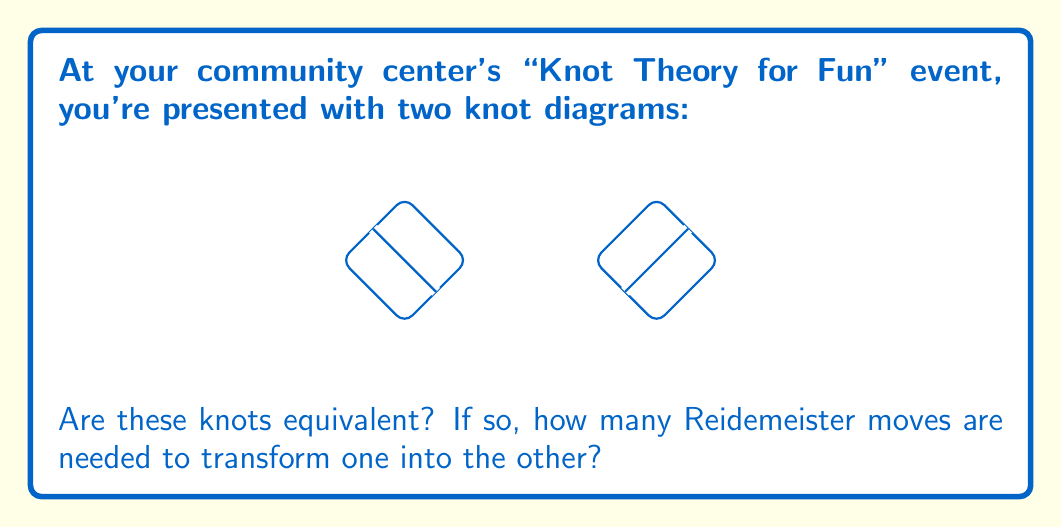Show me your answer to this math problem. To determine if two knots are equivalent using Reidemeister moves, we need to analyze the given diagrams and apply the appropriate moves. Let's approach this step-by-step:

1. Observe the knots:
   - Knot 1 is a right-handed trefoil knot
   - Knot 2 is a left-handed trefoil knot

2. Recall the three types of Reidemeister moves:
   - Type I: Twisting or untwisting a strand
   - Type II: Moving one strand completely over or under another
   - Type III: Moving a strand over or under a crossing

3. To transform the right-handed trefoil to a left-handed trefoil, we need to change all crossings. This can be done using Type III moves.

4. Procedure:
   a. Apply a Type III move to push the top strand under the crossing on the right.
   b. Apply another Type III move to push the resulting top strand under the crossing on the left.
   c. The knot is now transformed into the left-handed trefoil.

5. Count the moves:
   We used two Type III Reidemeister moves to transform one knot into the other.

Therefore, the knots are equivalent, and it takes 2 Reidemeister moves to transform one into the other.
Answer: Yes, 2 moves 